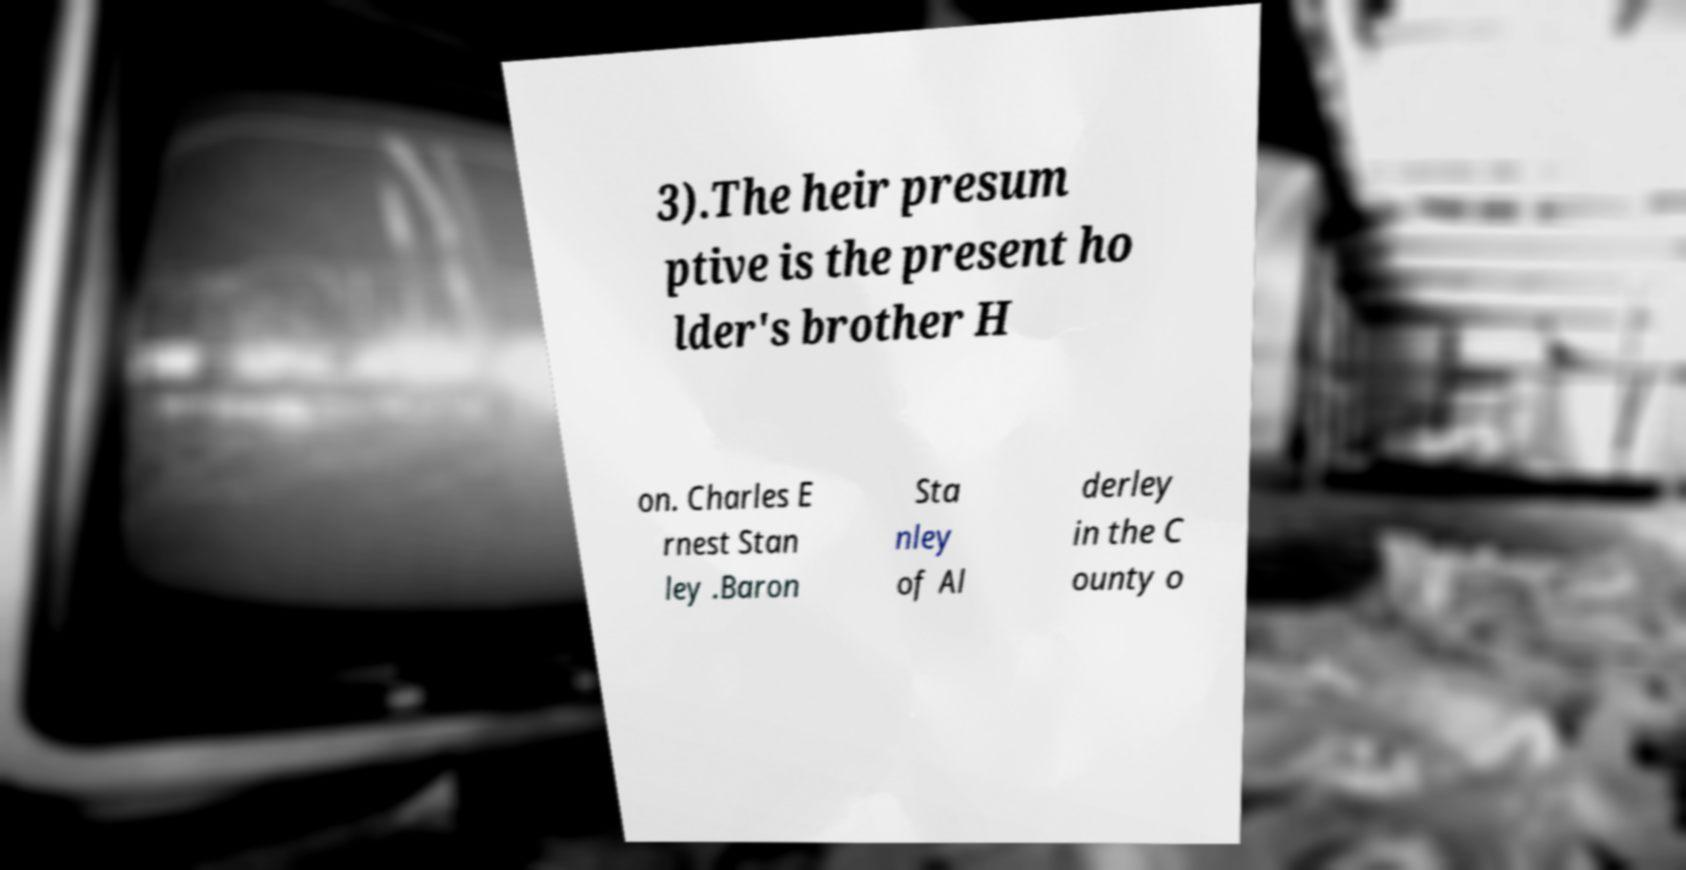I need the written content from this picture converted into text. Can you do that? 3).The heir presum ptive is the present ho lder's brother H on. Charles E rnest Stan ley .Baron Sta nley of Al derley in the C ounty o 